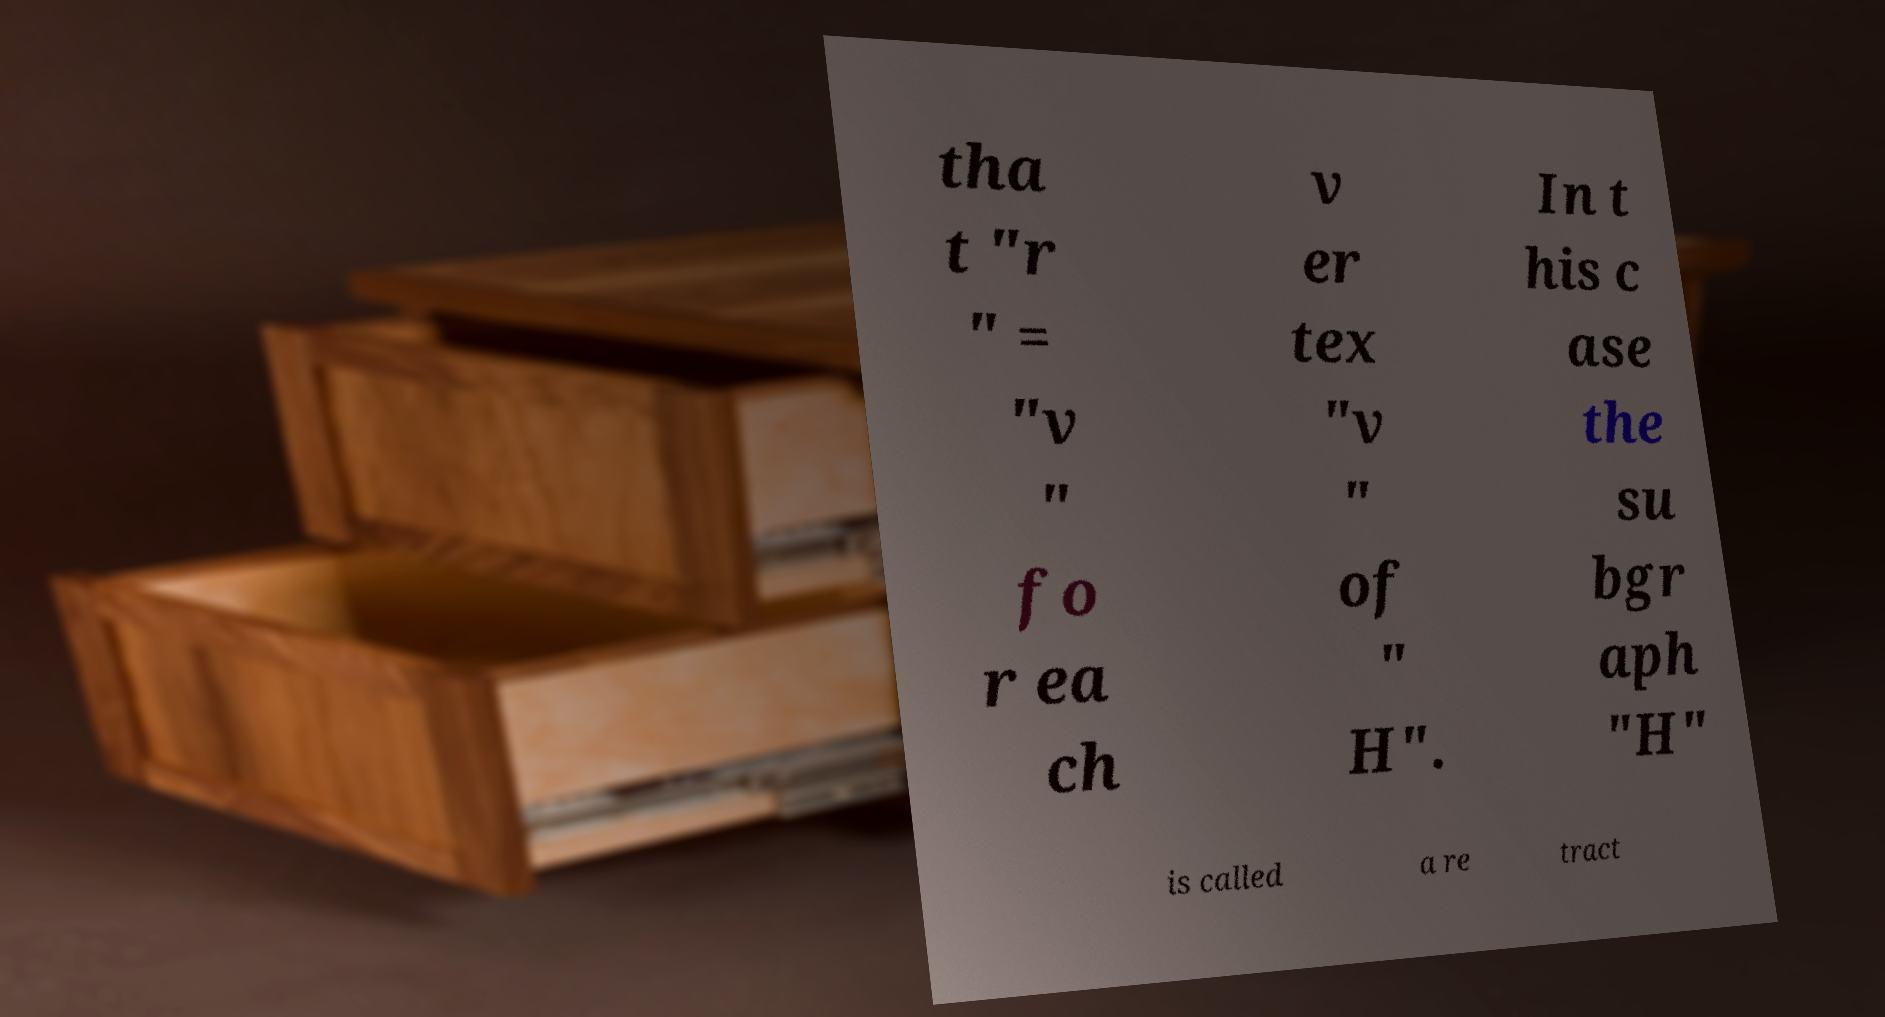What messages or text are displayed in this image? I need them in a readable, typed format. tha t "r " = "v " fo r ea ch v er tex "v " of " H". In t his c ase the su bgr aph "H" is called a re tract 